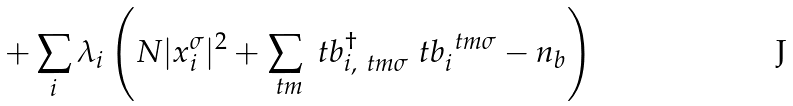Convert formula to latex. <formula><loc_0><loc_0><loc_500><loc_500>+ \sum _ { i } \lambda _ { i } \left ( N | x _ { i } ^ { \sigma } | ^ { 2 } + \sum _ { \ t m } \ t b _ { i , \ t m \sigma } ^ { \dagger } \ t b _ { i } ^ { \ t m \sigma } - n _ { b } \right )</formula> 